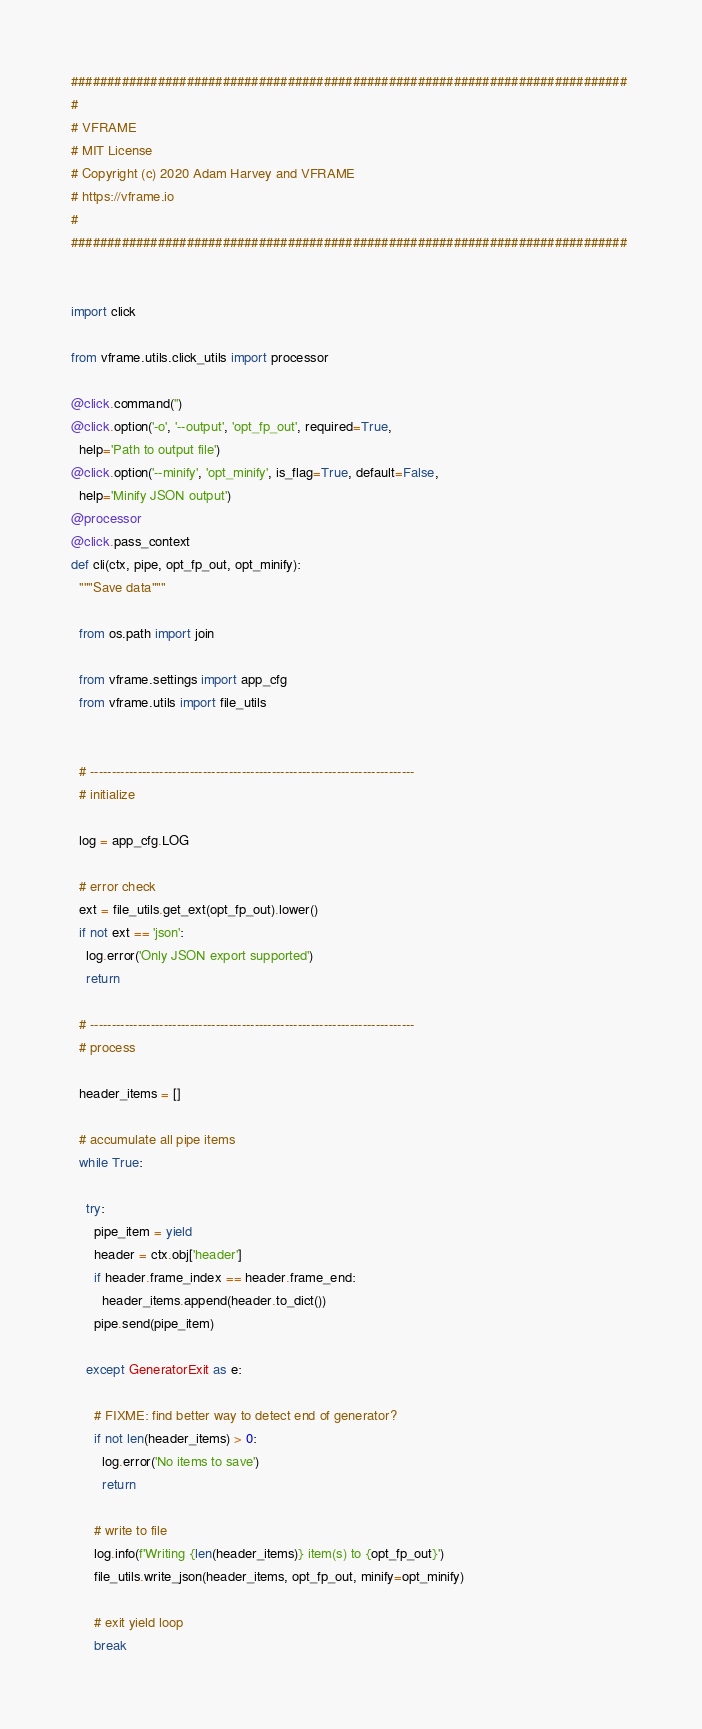<code> <loc_0><loc_0><loc_500><loc_500><_Python_>############################################################################# 
#
# VFRAME
# MIT License
# Copyright (c) 2020 Adam Harvey and VFRAME
# https://vframe.io 
#
#############################################################################


import click

from vframe.utils.click_utils import processor

@click.command('')
@click.option('-o', '--output', 'opt_fp_out', required=True,
  help='Path to output file')
@click.option('--minify', 'opt_minify', is_flag=True, default=False,
  help='Minify JSON output')
@processor
@click.pass_context
def cli(ctx, pipe, opt_fp_out, opt_minify):
  """Save data"""
  
  from os.path import join
  
  from vframe.settings import app_cfg
  from vframe.utils import file_utils

  
  # ---------------------------------------------------------------------------
  # initialize

  log = app_cfg.LOG

  # error check
  ext = file_utils.get_ext(opt_fp_out).lower()
  if not ext == 'json':
    log.error('Only JSON export supported')
    return

  # ---------------------------------------------------------------------------
  # process 

  header_items = []
  
  # accumulate all pipe items
  while True:

    try:
      pipe_item = yield
      header = ctx.obj['header']
      if header.frame_index == header.frame_end:
        header_items.append(header.to_dict())
      pipe.send(pipe_item)

    except GeneratorExit as e:

      # FIXME: find better way to detect end of generator?
      if not len(header_items) > 0:
        log.error('No items to save')
        return

      # write to file
      log.info(f'Writing {len(header_items)} item(s) to {opt_fp_out}')
      file_utils.write_json(header_items, opt_fp_out, minify=opt_minify)

      # exit yield loop
      break</code> 